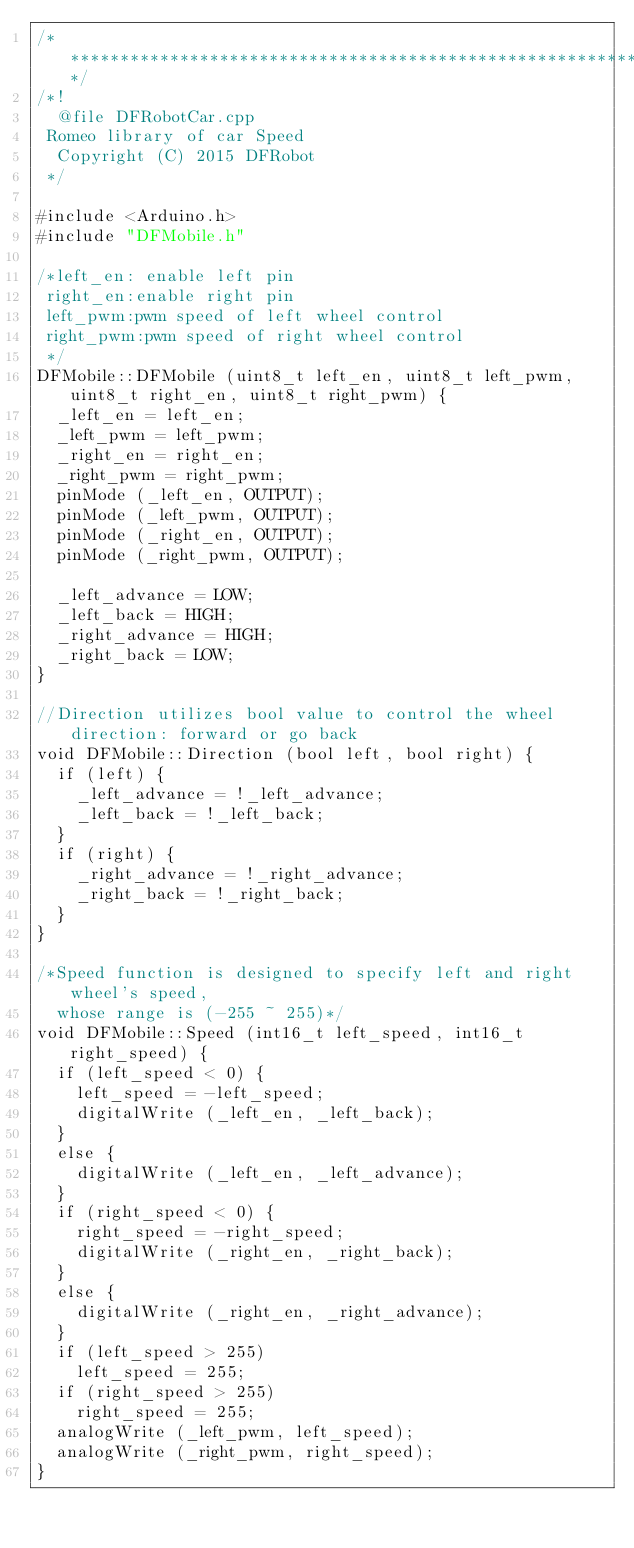Convert code to text. <code><loc_0><loc_0><loc_500><loc_500><_C++_>/**************************************************************************/
/*!
 	@file DFRobotCar.cpp
 Romeo library of car Speed
 	Copyright (C) 2015 DFRobot
 */

#include <Arduino.h>
#include "DFMobile.h"

/*left_en: enable left pin
 right_en:enable right pin
 left_pwm:pwm speed of left wheel control
 right_pwm:pwm speed of right wheel control
 */
DFMobile::DFMobile (uint8_t left_en, uint8_t left_pwm, uint8_t right_en, uint8_t right_pwm) {
  _left_en = left_en;
  _left_pwm = left_pwm;
  _right_en = right_en;
  _right_pwm = right_pwm;
  pinMode (_left_en, OUTPUT);
  pinMode (_left_pwm, OUTPUT);
  pinMode (_right_en, OUTPUT);
  pinMode (_right_pwm, OUTPUT);

  _left_advance = LOW;
  _left_back = HIGH;
  _right_advance = HIGH;
  _right_back = LOW;
}

//Direction utilizes bool value to control the wheel direction: forward or go back
void DFMobile::Direction (bool left, bool right) {
  if (left) {
    _left_advance = !_left_advance;
    _left_back = !_left_back;
  }
  if (right) {
    _right_advance = !_right_advance;
    _right_back = !_right_back;
  }
}

/*Speed function is designed to specify left and right wheel's speed, 
  whose range is (-255 ~ 255)*/ 
void DFMobile::Speed (int16_t left_speed, int16_t right_speed) {
  if (left_speed < 0) {
    left_speed = -left_speed;
    digitalWrite (_left_en, _left_back);
  } 
  else {
    digitalWrite (_left_en, _left_advance);
  }
  if (right_speed < 0) {
    right_speed = -right_speed;
    digitalWrite (_right_en, _right_back);
  } 
  else {
    digitalWrite (_right_en, _right_advance);
  }
  if (left_speed > 255)
    left_speed = 255;
  if (right_speed > 255)
    right_speed = 255;
  analogWrite (_left_pwm, left_speed);
  analogWrite (_right_pwm, right_speed);
}



</code> 